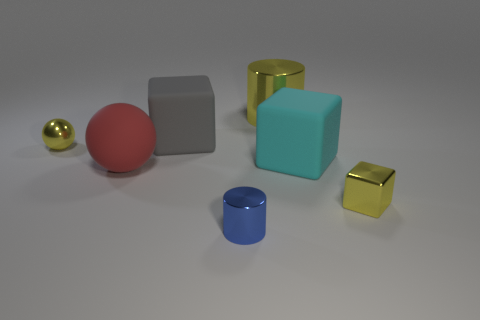Add 1 gray matte cubes. How many objects exist? 8 Subtract all cylinders. How many objects are left? 5 Add 5 tiny metallic cylinders. How many tiny metallic cylinders are left? 6 Add 5 big red spheres. How many big red spheres exist? 6 Subtract 0 green balls. How many objects are left? 7 Subtract all tiny cyan shiny cylinders. Subtract all blue cylinders. How many objects are left? 6 